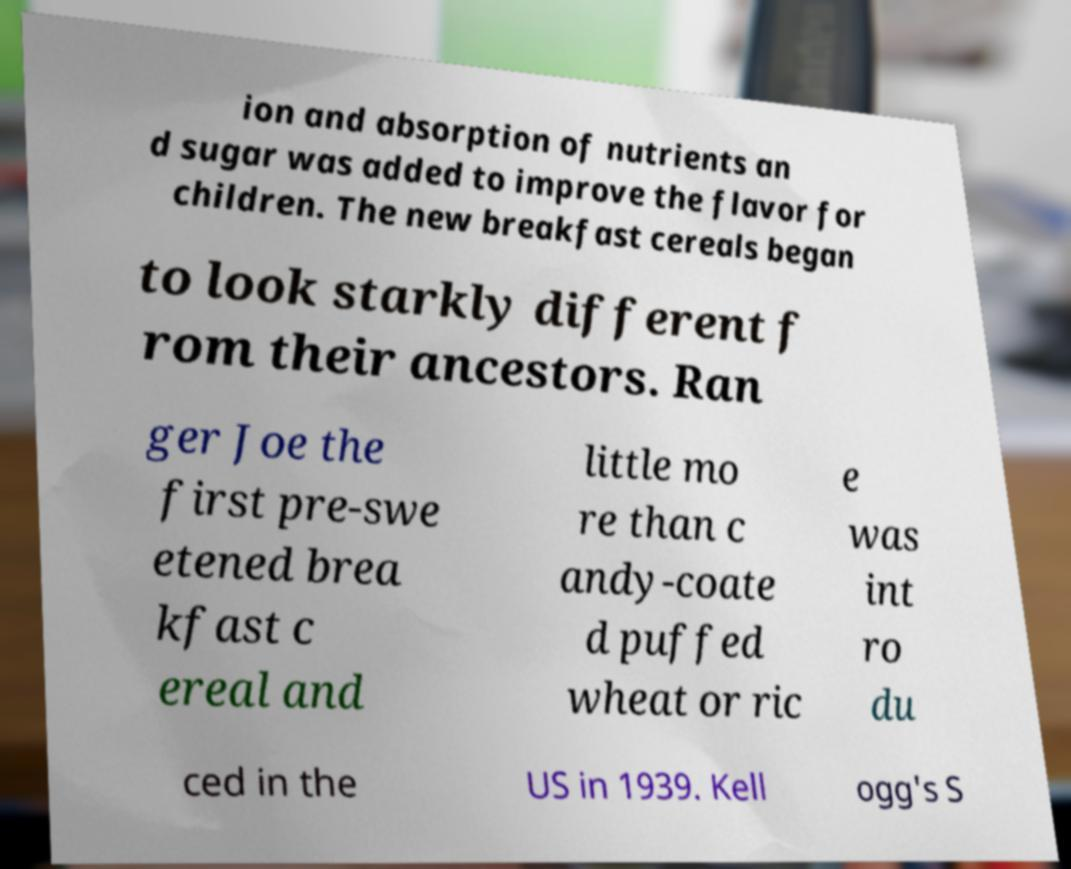Please read and relay the text visible in this image. What does it say? ion and absorption of nutrients an d sugar was added to improve the flavor for children. The new breakfast cereals began to look starkly different f rom their ancestors. Ran ger Joe the first pre-swe etened brea kfast c ereal and little mo re than c andy-coate d puffed wheat or ric e was int ro du ced in the US in 1939. Kell ogg's S 